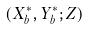<formula> <loc_0><loc_0><loc_500><loc_500>( X _ { b } ^ { * } , Y _ { b } ^ { * } ; Z )</formula> 